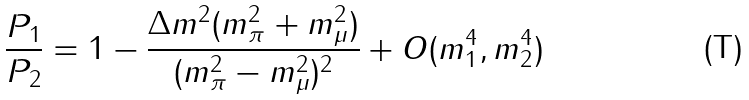Convert formula to latex. <formula><loc_0><loc_0><loc_500><loc_500>\frac { P _ { 1 } } { P _ { 2 } } = 1 - \frac { \Delta m ^ { 2 } ( m _ { \pi } ^ { 2 } + m _ { \mu } ^ { 2 } ) } { ( m _ { \pi } ^ { 2 } - m _ { \mu } ^ { 2 } ) ^ { 2 } } + O ( m _ { 1 } ^ { 4 } , m _ { 2 } ^ { 4 } )</formula> 